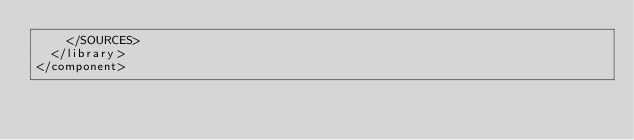<code> <loc_0><loc_0><loc_500><loc_500><_XML_>    </SOURCES>
  </library>
</component></code> 